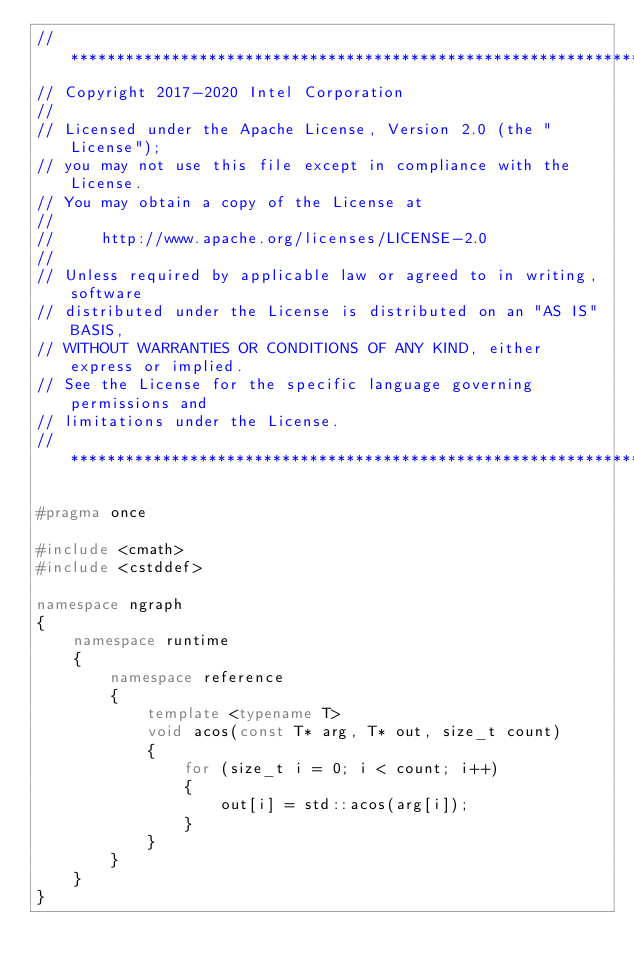<code> <loc_0><loc_0><loc_500><loc_500><_C++_>//*****************************************************************************
// Copyright 2017-2020 Intel Corporation
//
// Licensed under the Apache License, Version 2.0 (the "License");
// you may not use this file except in compliance with the License.
// You may obtain a copy of the License at
//
//     http://www.apache.org/licenses/LICENSE-2.0
//
// Unless required by applicable law or agreed to in writing, software
// distributed under the License is distributed on an "AS IS" BASIS,
// WITHOUT WARRANTIES OR CONDITIONS OF ANY KIND, either express or implied.
// See the License for the specific language governing permissions and
// limitations under the License.
//*****************************************************************************

#pragma once

#include <cmath>
#include <cstddef>

namespace ngraph
{
    namespace runtime
    {
        namespace reference
        {
            template <typename T>
            void acos(const T* arg, T* out, size_t count)
            {
                for (size_t i = 0; i < count; i++)
                {
                    out[i] = std::acos(arg[i]);
                }
            }
        }
    }
}
</code> 